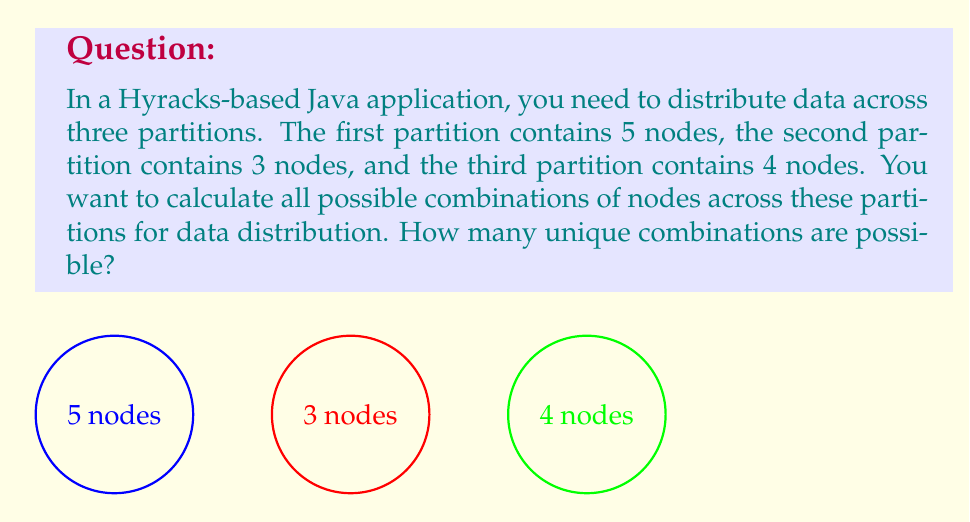Help me with this question. To solve this problem, we need to understand the concept of Cartesian product and its cardinality. 

1. Let's define our sets:
   $A = \{a_1, a_2, a_3, a_4, a_5\}$ (5 nodes in the first partition)
   $B = \{b_1, b_2, b_3\}$ (3 nodes in the second partition)
   $C = \{c_1, c_2, c_3, c_4\}$ (4 nodes in the third partition)

2. We need to find the cardinality of the Cartesian product $A \times B \times C$.

3. The Cartesian product $A \times B \times C$ is the set of all ordered triples $(a, b, c)$ where $a \in A$, $b \in B$, and $c \in C$.

4. The cardinality of a Cartesian product of finite sets is equal to the product of the cardinalities of the individual sets:

   $|A \times B \times C| = |A| \cdot |B| \cdot |C|$

5. We know the cardinalities of our sets:
   $|A| = 5$
   $|B| = 3$
   $|C| = 4$

6. Applying the formula:
   $|A \times B \times C| = 5 \cdot 3 \cdot 4 = 60$

Therefore, there are 60 unique combinations of nodes across the three partitions.
Answer: 60 